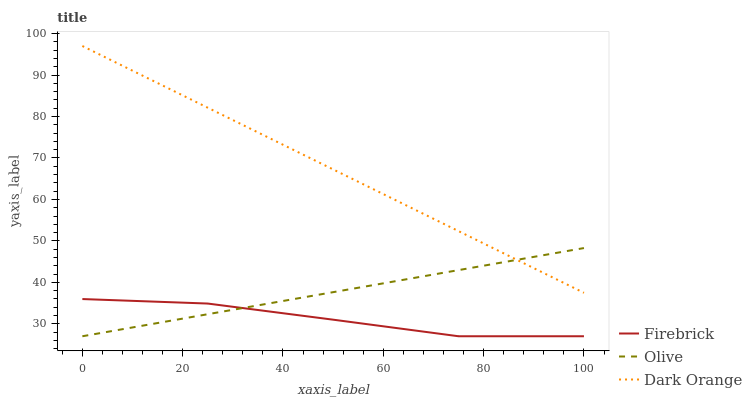Does Firebrick have the minimum area under the curve?
Answer yes or no. Yes. Does Dark Orange have the maximum area under the curve?
Answer yes or no. Yes. Does Dark Orange have the minimum area under the curve?
Answer yes or no. No. Does Firebrick have the maximum area under the curve?
Answer yes or no. No. Is Olive the smoothest?
Answer yes or no. Yes. Is Firebrick the roughest?
Answer yes or no. Yes. Is Dark Orange the smoothest?
Answer yes or no. No. Is Dark Orange the roughest?
Answer yes or no. No. Does Olive have the lowest value?
Answer yes or no. Yes. Does Dark Orange have the lowest value?
Answer yes or no. No. Does Dark Orange have the highest value?
Answer yes or no. Yes. Does Firebrick have the highest value?
Answer yes or no. No. Is Firebrick less than Dark Orange?
Answer yes or no. Yes. Is Dark Orange greater than Firebrick?
Answer yes or no. Yes. Does Firebrick intersect Olive?
Answer yes or no. Yes. Is Firebrick less than Olive?
Answer yes or no. No. Is Firebrick greater than Olive?
Answer yes or no. No. Does Firebrick intersect Dark Orange?
Answer yes or no. No. 